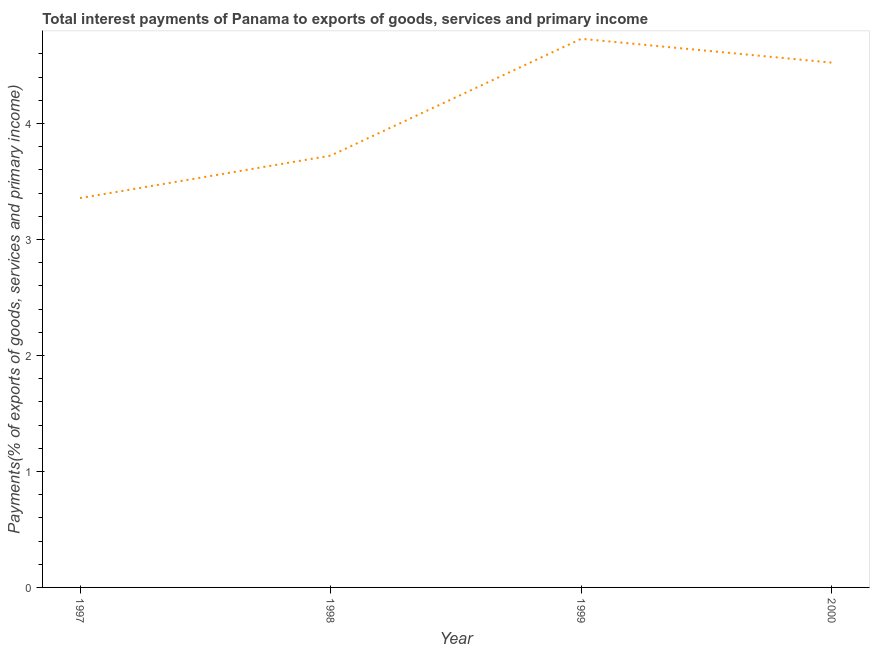What is the total interest payments on external debt in 1999?
Provide a short and direct response. 4.73. Across all years, what is the maximum total interest payments on external debt?
Your answer should be compact. 4.73. Across all years, what is the minimum total interest payments on external debt?
Your answer should be very brief. 3.36. In which year was the total interest payments on external debt maximum?
Your answer should be very brief. 1999. What is the sum of the total interest payments on external debt?
Your answer should be very brief. 16.34. What is the difference between the total interest payments on external debt in 1997 and 2000?
Your answer should be compact. -1.17. What is the average total interest payments on external debt per year?
Provide a succinct answer. 4.08. What is the median total interest payments on external debt?
Keep it short and to the point. 4.12. In how many years, is the total interest payments on external debt greater than 2.2 %?
Keep it short and to the point. 4. Do a majority of the years between 1997 and 2000 (inclusive) have total interest payments on external debt greater than 4.2 %?
Keep it short and to the point. No. What is the ratio of the total interest payments on external debt in 1999 to that in 2000?
Offer a very short reply. 1.05. What is the difference between the highest and the second highest total interest payments on external debt?
Provide a succinct answer. 0.21. Is the sum of the total interest payments on external debt in 1997 and 1999 greater than the maximum total interest payments on external debt across all years?
Your answer should be compact. Yes. What is the difference between the highest and the lowest total interest payments on external debt?
Your answer should be compact. 1.37. In how many years, is the total interest payments on external debt greater than the average total interest payments on external debt taken over all years?
Keep it short and to the point. 2. Does the total interest payments on external debt monotonically increase over the years?
Offer a very short reply. No. Does the graph contain any zero values?
Provide a succinct answer. No. Does the graph contain grids?
Give a very brief answer. No. What is the title of the graph?
Keep it short and to the point. Total interest payments of Panama to exports of goods, services and primary income. What is the label or title of the Y-axis?
Provide a short and direct response. Payments(% of exports of goods, services and primary income). What is the Payments(% of exports of goods, services and primary income) of 1997?
Ensure brevity in your answer.  3.36. What is the Payments(% of exports of goods, services and primary income) of 1998?
Your answer should be compact. 3.72. What is the Payments(% of exports of goods, services and primary income) in 1999?
Offer a terse response. 4.73. What is the Payments(% of exports of goods, services and primary income) of 2000?
Offer a terse response. 4.52. What is the difference between the Payments(% of exports of goods, services and primary income) in 1997 and 1998?
Your answer should be very brief. -0.37. What is the difference between the Payments(% of exports of goods, services and primary income) in 1997 and 1999?
Your response must be concise. -1.37. What is the difference between the Payments(% of exports of goods, services and primary income) in 1997 and 2000?
Ensure brevity in your answer.  -1.17. What is the difference between the Payments(% of exports of goods, services and primary income) in 1998 and 1999?
Your answer should be compact. -1.01. What is the difference between the Payments(% of exports of goods, services and primary income) in 1998 and 2000?
Give a very brief answer. -0.8. What is the difference between the Payments(% of exports of goods, services and primary income) in 1999 and 2000?
Your answer should be compact. 0.21. What is the ratio of the Payments(% of exports of goods, services and primary income) in 1997 to that in 1998?
Your answer should be compact. 0.9. What is the ratio of the Payments(% of exports of goods, services and primary income) in 1997 to that in 1999?
Your answer should be very brief. 0.71. What is the ratio of the Payments(% of exports of goods, services and primary income) in 1997 to that in 2000?
Provide a succinct answer. 0.74. What is the ratio of the Payments(% of exports of goods, services and primary income) in 1998 to that in 1999?
Your answer should be very brief. 0.79. What is the ratio of the Payments(% of exports of goods, services and primary income) in 1998 to that in 2000?
Ensure brevity in your answer.  0.82. What is the ratio of the Payments(% of exports of goods, services and primary income) in 1999 to that in 2000?
Provide a short and direct response. 1.04. 